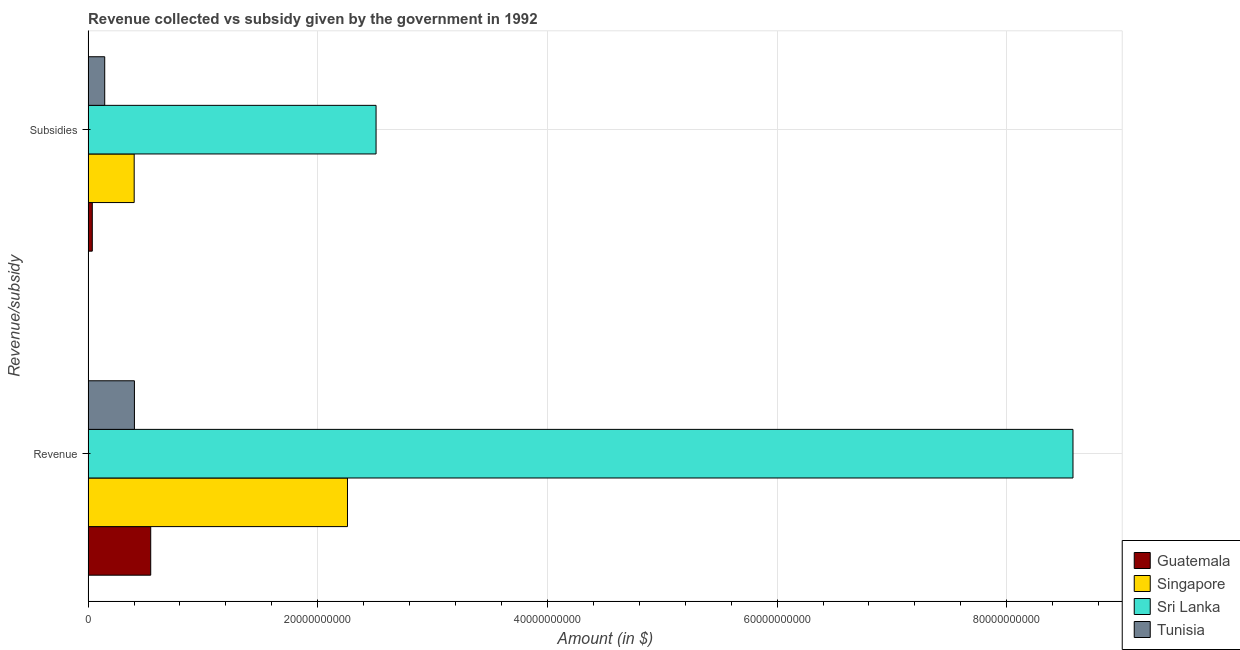How many groups of bars are there?
Keep it short and to the point. 2. How many bars are there on the 1st tick from the top?
Your response must be concise. 4. What is the label of the 1st group of bars from the top?
Keep it short and to the point. Subsidies. What is the amount of subsidies given in Sri Lanka?
Provide a succinct answer. 2.51e+1. Across all countries, what is the maximum amount of subsidies given?
Keep it short and to the point. 2.51e+1. Across all countries, what is the minimum amount of subsidies given?
Your response must be concise. 3.67e+08. In which country was the amount of revenue collected maximum?
Your response must be concise. Sri Lanka. In which country was the amount of revenue collected minimum?
Give a very brief answer. Tunisia. What is the total amount of subsidies given in the graph?
Make the answer very short. 3.09e+1. What is the difference between the amount of subsidies given in Sri Lanka and that in Singapore?
Offer a very short reply. 2.11e+1. What is the difference between the amount of subsidies given in Singapore and the amount of revenue collected in Sri Lanka?
Your answer should be very brief. -8.18e+1. What is the average amount of revenue collected per country?
Offer a very short reply. 2.95e+1. What is the difference between the amount of revenue collected and amount of subsidies given in Tunisia?
Ensure brevity in your answer.  2.59e+09. In how many countries, is the amount of revenue collected greater than 68000000000 $?
Offer a terse response. 1. What is the ratio of the amount of subsidies given in Sri Lanka to that in Tunisia?
Give a very brief answer. 17.32. In how many countries, is the amount of revenue collected greater than the average amount of revenue collected taken over all countries?
Offer a terse response. 1. What does the 2nd bar from the top in Revenue represents?
Keep it short and to the point. Sri Lanka. What does the 3rd bar from the bottom in Revenue represents?
Your response must be concise. Sri Lanka. How many bars are there?
Make the answer very short. 8. Are all the bars in the graph horizontal?
Offer a terse response. Yes. How many countries are there in the graph?
Give a very brief answer. 4. What is the difference between two consecutive major ticks on the X-axis?
Provide a short and direct response. 2.00e+1. Are the values on the major ticks of X-axis written in scientific E-notation?
Your answer should be compact. No. Does the graph contain any zero values?
Your response must be concise. No. Where does the legend appear in the graph?
Provide a short and direct response. Bottom right. What is the title of the graph?
Make the answer very short. Revenue collected vs subsidy given by the government in 1992. Does "Middle East & North Africa (developing only)" appear as one of the legend labels in the graph?
Make the answer very short. No. What is the label or title of the X-axis?
Offer a very short reply. Amount (in $). What is the label or title of the Y-axis?
Keep it short and to the point. Revenue/subsidy. What is the Amount (in $) of Guatemala in Revenue?
Make the answer very short. 5.45e+09. What is the Amount (in $) of Singapore in Revenue?
Your answer should be compact. 2.26e+1. What is the Amount (in $) of Sri Lanka in Revenue?
Offer a very short reply. 8.58e+1. What is the Amount (in $) in Tunisia in Revenue?
Provide a succinct answer. 4.03e+09. What is the Amount (in $) of Guatemala in Subsidies?
Provide a succinct answer. 3.67e+08. What is the Amount (in $) in Singapore in Subsidies?
Provide a short and direct response. 4.01e+09. What is the Amount (in $) of Sri Lanka in Subsidies?
Your answer should be very brief. 2.51e+1. What is the Amount (in $) of Tunisia in Subsidies?
Ensure brevity in your answer.  1.45e+09. Across all Revenue/subsidy, what is the maximum Amount (in $) of Guatemala?
Your answer should be compact. 5.45e+09. Across all Revenue/subsidy, what is the maximum Amount (in $) in Singapore?
Ensure brevity in your answer.  2.26e+1. Across all Revenue/subsidy, what is the maximum Amount (in $) in Sri Lanka?
Provide a short and direct response. 8.58e+1. Across all Revenue/subsidy, what is the maximum Amount (in $) in Tunisia?
Give a very brief answer. 4.03e+09. Across all Revenue/subsidy, what is the minimum Amount (in $) in Guatemala?
Give a very brief answer. 3.67e+08. Across all Revenue/subsidy, what is the minimum Amount (in $) of Singapore?
Provide a succinct answer. 4.01e+09. Across all Revenue/subsidy, what is the minimum Amount (in $) in Sri Lanka?
Provide a short and direct response. 2.51e+1. Across all Revenue/subsidy, what is the minimum Amount (in $) in Tunisia?
Your answer should be compact. 1.45e+09. What is the total Amount (in $) in Guatemala in the graph?
Make the answer very short. 5.82e+09. What is the total Amount (in $) in Singapore in the graph?
Give a very brief answer. 2.66e+1. What is the total Amount (in $) in Sri Lanka in the graph?
Keep it short and to the point. 1.11e+11. What is the total Amount (in $) in Tunisia in the graph?
Your response must be concise. 5.48e+09. What is the difference between the Amount (in $) of Guatemala in Revenue and that in Subsidies?
Your response must be concise. 5.09e+09. What is the difference between the Amount (in $) in Singapore in Revenue and that in Subsidies?
Make the answer very short. 1.86e+1. What is the difference between the Amount (in $) of Sri Lanka in Revenue and that in Subsidies?
Offer a terse response. 6.07e+1. What is the difference between the Amount (in $) of Tunisia in Revenue and that in Subsidies?
Your response must be concise. 2.59e+09. What is the difference between the Amount (in $) in Guatemala in Revenue and the Amount (in $) in Singapore in Subsidies?
Provide a short and direct response. 1.44e+09. What is the difference between the Amount (in $) of Guatemala in Revenue and the Amount (in $) of Sri Lanka in Subsidies?
Your answer should be very brief. -1.96e+1. What is the difference between the Amount (in $) of Guatemala in Revenue and the Amount (in $) of Tunisia in Subsidies?
Give a very brief answer. 4.01e+09. What is the difference between the Amount (in $) of Singapore in Revenue and the Amount (in $) of Sri Lanka in Subsidies?
Provide a succinct answer. -2.49e+09. What is the difference between the Amount (in $) in Singapore in Revenue and the Amount (in $) in Tunisia in Subsidies?
Your answer should be very brief. 2.11e+1. What is the difference between the Amount (in $) of Sri Lanka in Revenue and the Amount (in $) of Tunisia in Subsidies?
Keep it short and to the point. 8.43e+1. What is the average Amount (in $) of Guatemala per Revenue/subsidy?
Provide a succinct answer. 2.91e+09. What is the average Amount (in $) of Singapore per Revenue/subsidy?
Keep it short and to the point. 1.33e+1. What is the average Amount (in $) of Sri Lanka per Revenue/subsidy?
Provide a short and direct response. 5.54e+1. What is the average Amount (in $) in Tunisia per Revenue/subsidy?
Offer a terse response. 2.74e+09. What is the difference between the Amount (in $) in Guatemala and Amount (in $) in Singapore in Revenue?
Offer a terse response. -1.71e+1. What is the difference between the Amount (in $) in Guatemala and Amount (in $) in Sri Lanka in Revenue?
Your answer should be compact. -8.03e+1. What is the difference between the Amount (in $) of Guatemala and Amount (in $) of Tunisia in Revenue?
Ensure brevity in your answer.  1.42e+09. What is the difference between the Amount (in $) of Singapore and Amount (in $) of Sri Lanka in Revenue?
Provide a succinct answer. -6.32e+1. What is the difference between the Amount (in $) in Singapore and Amount (in $) in Tunisia in Revenue?
Offer a very short reply. 1.86e+1. What is the difference between the Amount (in $) in Sri Lanka and Amount (in $) in Tunisia in Revenue?
Ensure brevity in your answer.  8.17e+1. What is the difference between the Amount (in $) in Guatemala and Amount (in $) in Singapore in Subsidies?
Provide a succinct answer. -3.65e+09. What is the difference between the Amount (in $) of Guatemala and Amount (in $) of Sri Lanka in Subsidies?
Your answer should be very brief. -2.47e+1. What is the difference between the Amount (in $) of Guatemala and Amount (in $) of Tunisia in Subsidies?
Offer a very short reply. -1.08e+09. What is the difference between the Amount (in $) of Singapore and Amount (in $) of Sri Lanka in Subsidies?
Your response must be concise. -2.11e+1. What is the difference between the Amount (in $) of Singapore and Amount (in $) of Tunisia in Subsidies?
Provide a short and direct response. 2.57e+09. What is the difference between the Amount (in $) of Sri Lanka and Amount (in $) of Tunisia in Subsidies?
Your answer should be very brief. 2.36e+1. What is the ratio of the Amount (in $) of Guatemala in Revenue to that in Subsidies?
Keep it short and to the point. 14.87. What is the ratio of the Amount (in $) in Singapore in Revenue to that in Subsidies?
Keep it short and to the point. 5.63. What is the ratio of the Amount (in $) in Sri Lanka in Revenue to that in Subsidies?
Your response must be concise. 3.42. What is the ratio of the Amount (in $) in Tunisia in Revenue to that in Subsidies?
Provide a succinct answer. 2.79. What is the difference between the highest and the second highest Amount (in $) of Guatemala?
Give a very brief answer. 5.09e+09. What is the difference between the highest and the second highest Amount (in $) of Singapore?
Provide a short and direct response. 1.86e+1. What is the difference between the highest and the second highest Amount (in $) in Sri Lanka?
Give a very brief answer. 6.07e+1. What is the difference between the highest and the second highest Amount (in $) in Tunisia?
Your answer should be compact. 2.59e+09. What is the difference between the highest and the lowest Amount (in $) in Guatemala?
Offer a very short reply. 5.09e+09. What is the difference between the highest and the lowest Amount (in $) in Singapore?
Offer a terse response. 1.86e+1. What is the difference between the highest and the lowest Amount (in $) of Sri Lanka?
Offer a very short reply. 6.07e+1. What is the difference between the highest and the lowest Amount (in $) of Tunisia?
Offer a terse response. 2.59e+09. 